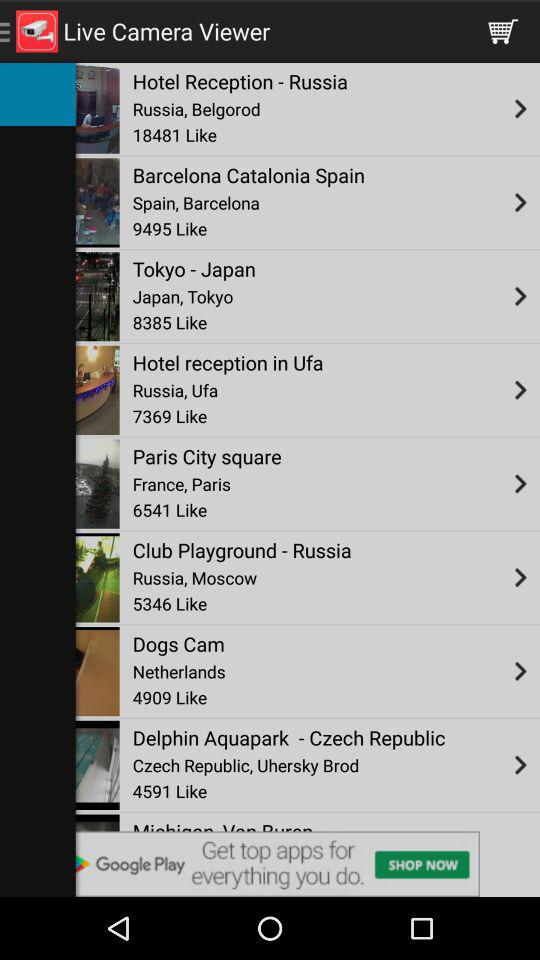What live camera viewer has 6541 likes? The live camera viewer that has 6541 likes is "Paris City square". 